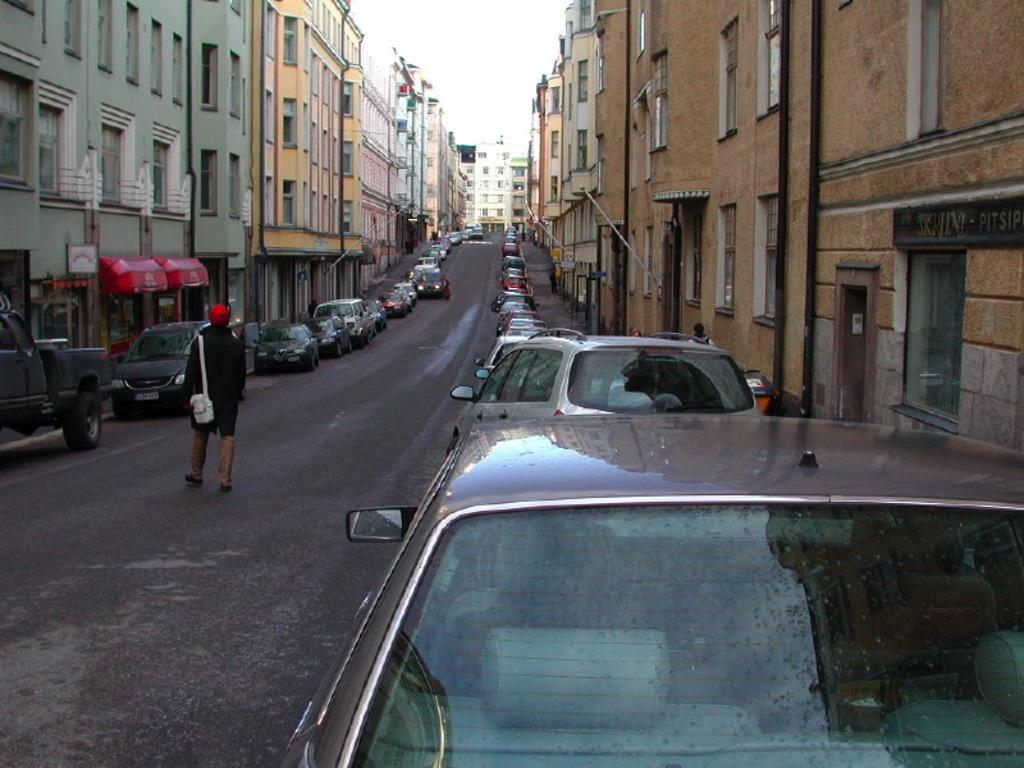What type of vehicles are present in the image? There are cars in the image. Where are the cars located in relation to the buildings? The cars are between buildings in the image. What is the person in the image doing? The person is walking on the road in the image. What can be seen at the top of the image? The sky is visible at the top of the image. What type of nose can be seen on the person walking in the image? There is no nose visible on the person walking in the image, as the person is facing away from the camera. 